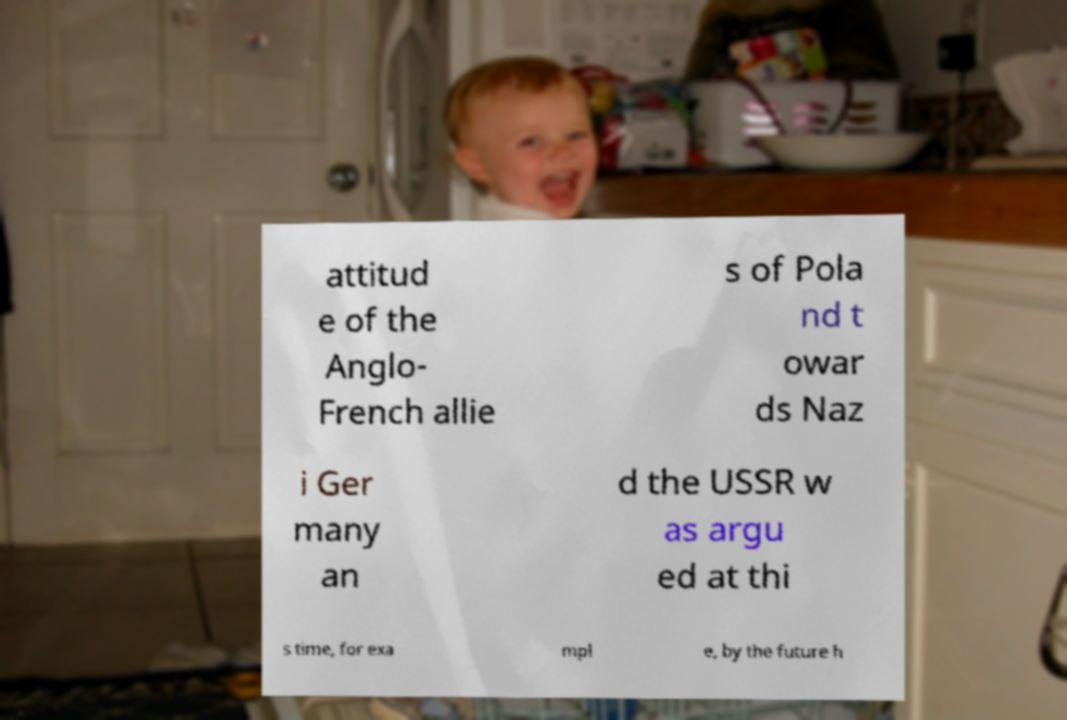What messages or text are displayed in this image? I need them in a readable, typed format. attitud e of the Anglo- French allie s of Pola nd t owar ds Naz i Ger many an d the USSR w as argu ed at thi s time, for exa mpl e, by the future h 